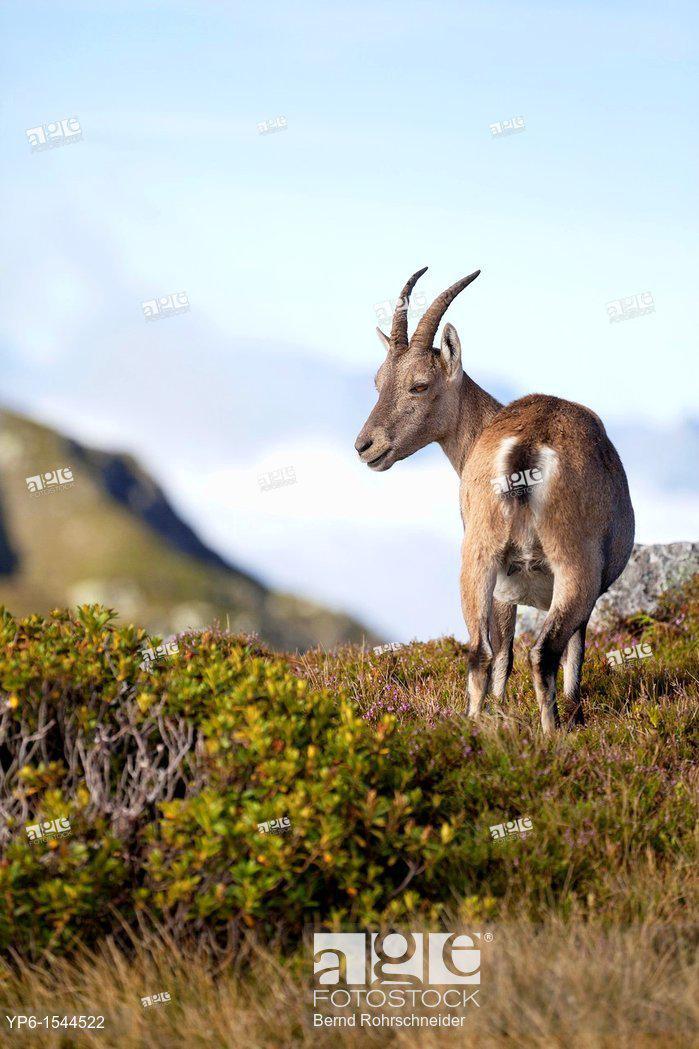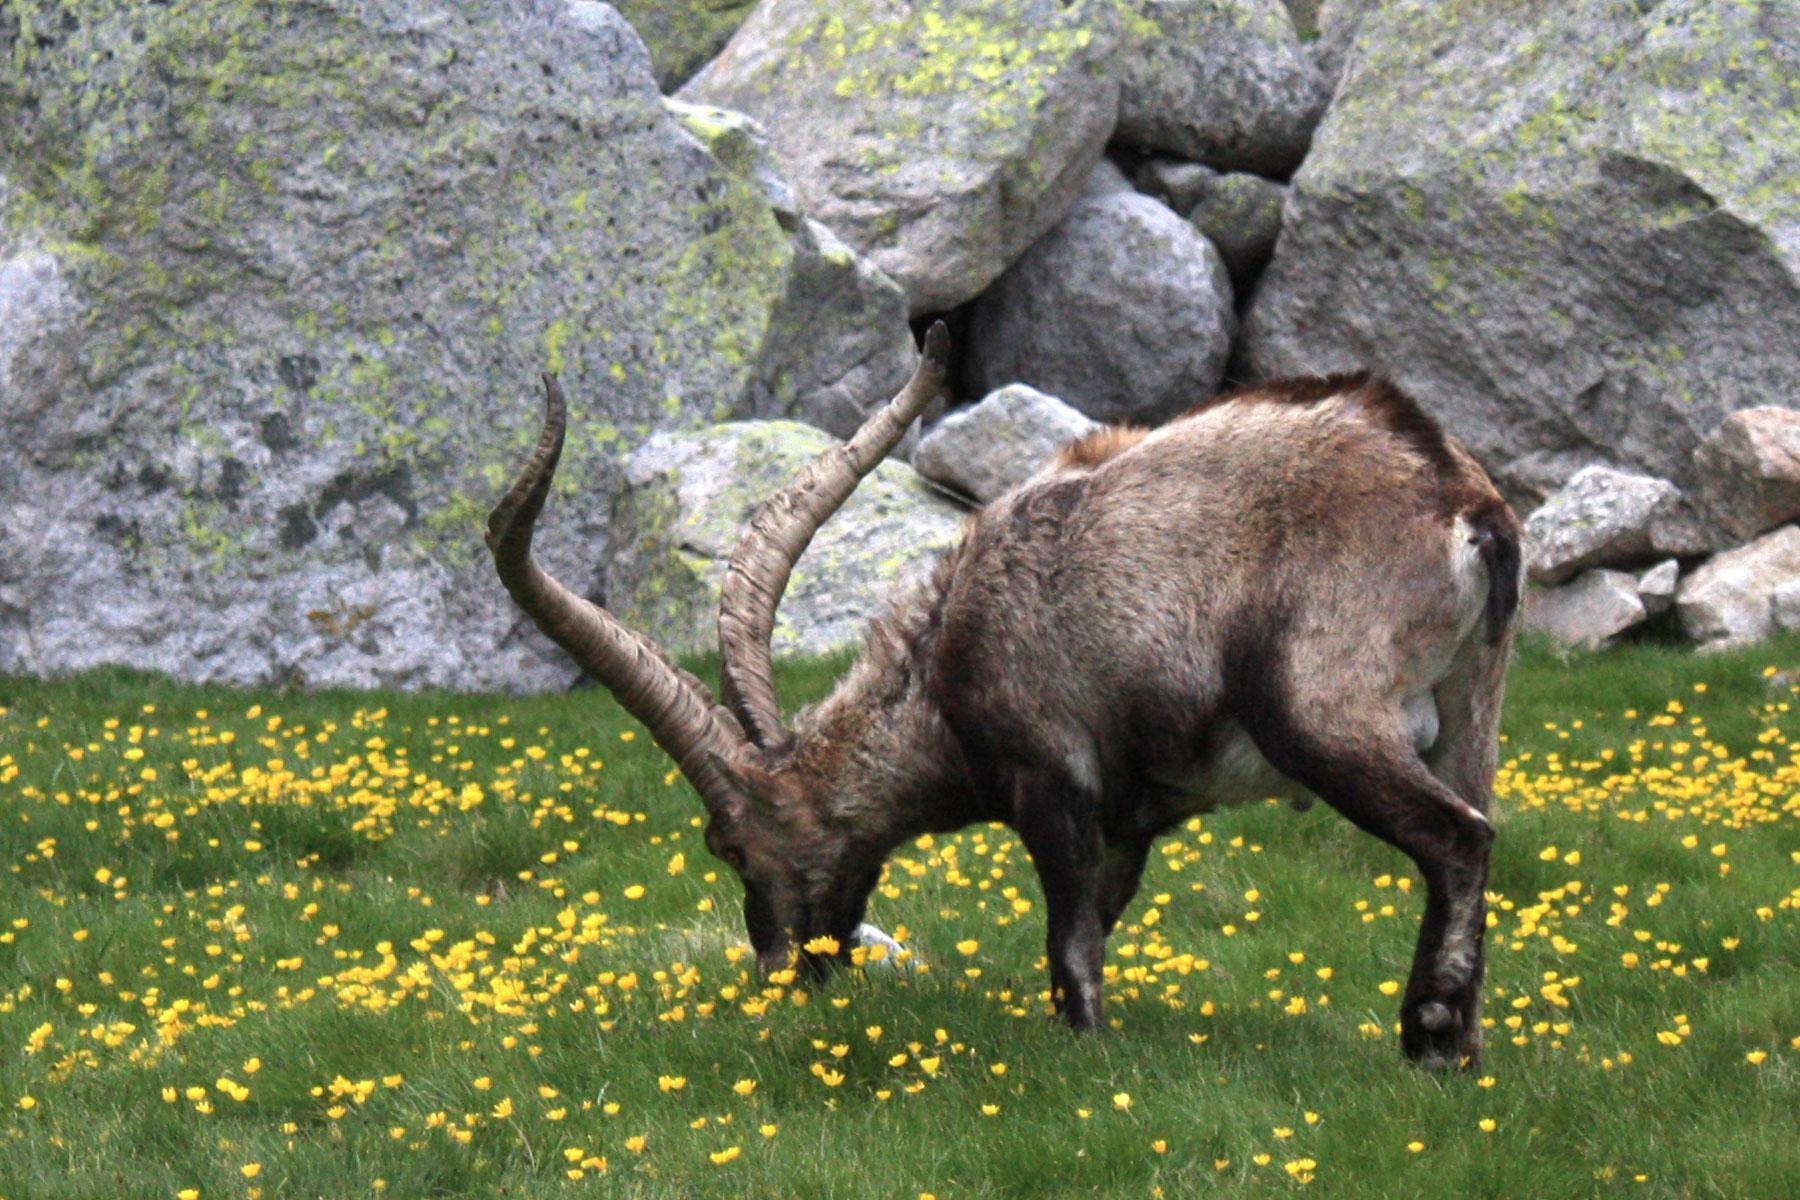The first image is the image on the left, the second image is the image on the right. Analyze the images presented: Is the assertion "The left image has a single mammal looking to the right, the right image has a single mammal not looking to the right." valid? Answer yes or no. No. The first image is the image on the left, the second image is the image on the right. Evaluate the accuracy of this statement regarding the images: "The left and right image contains the same number of goats with at least one one rocks.". Is it true? Answer yes or no. No. 